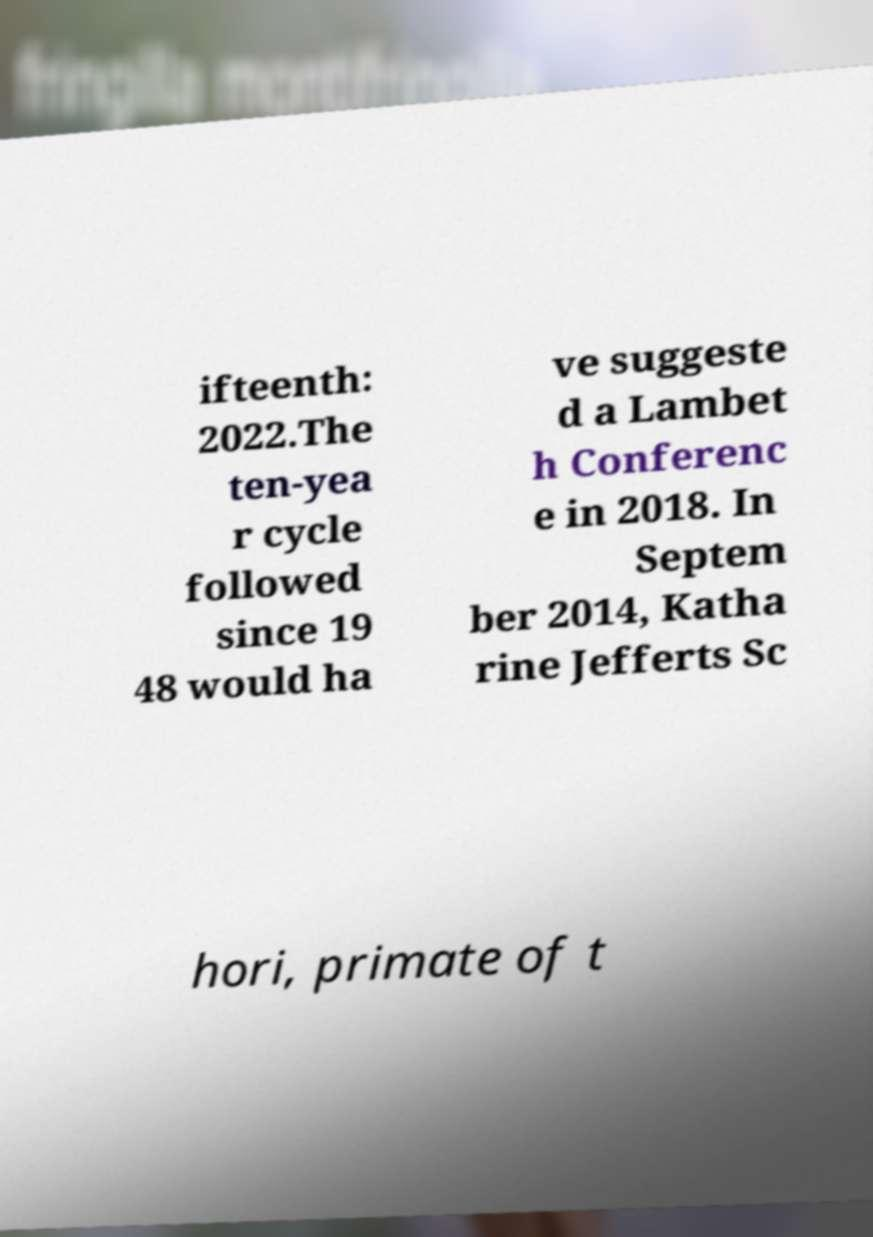Could you extract and type out the text from this image? ifteenth: 2022.The ten-yea r cycle followed since 19 48 would ha ve suggeste d a Lambet h Conferenc e in 2018. In Septem ber 2014, Katha rine Jefferts Sc hori, primate of t 